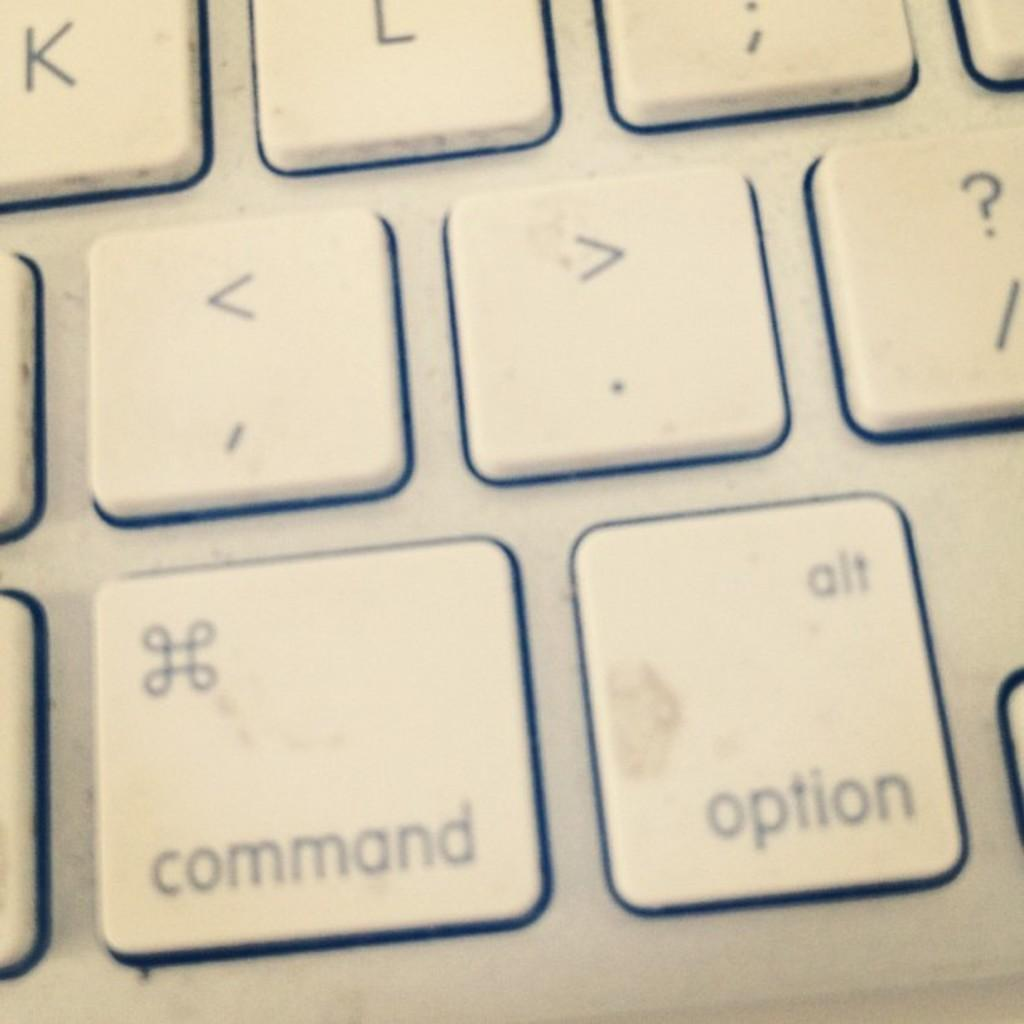<image>
Create a compact narrative representing the image presented. A close up of some buttons on a keyboard say "command" and "option". 